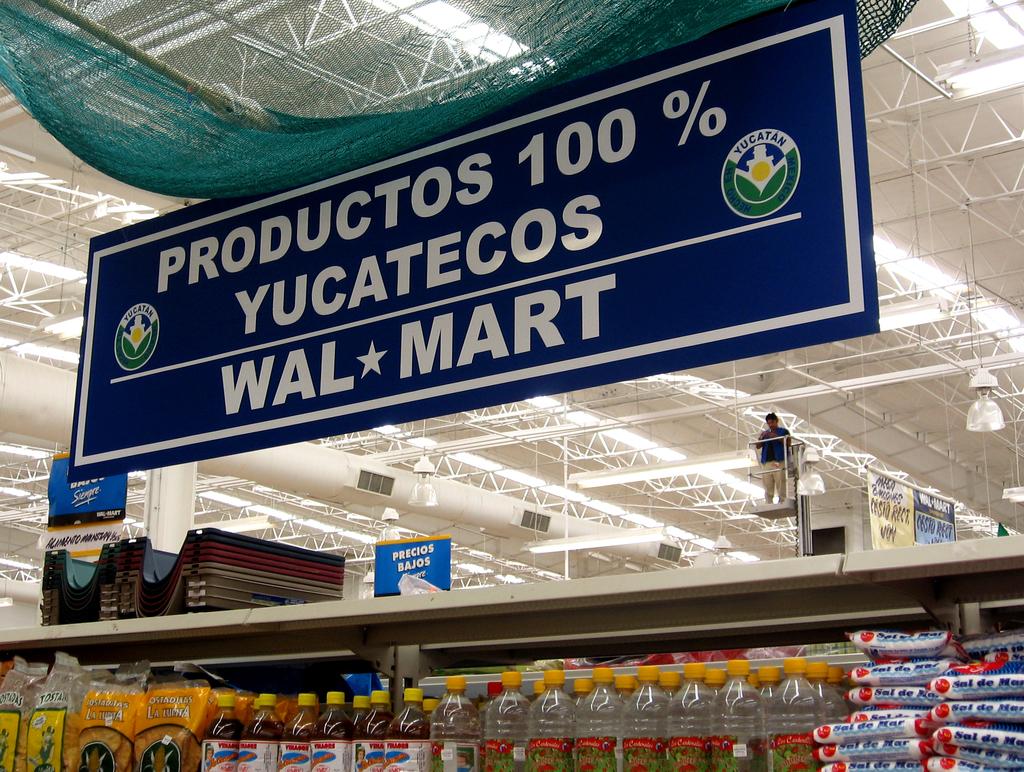What store is shown here?
Provide a short and direct response. Walmart. What is the number before the % sign?
Keep it short and to the point. 100. 